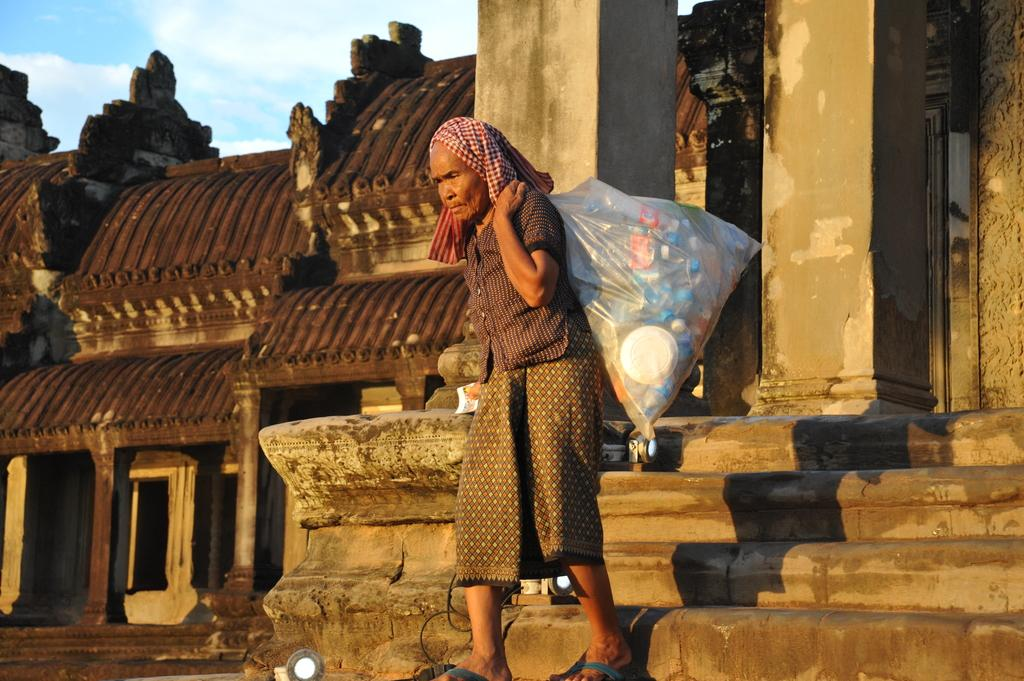Who is the main subject in the image? There is an old woman in the image. What is the old woman carrying? The old woman is carrying a bag of plastic bottles. Where is the old woman walking? The old woman is walking on the steps. What can be seen in the background of the image? There are ancient buildings in the background of the image. What is visible in the sky in the image? The sky is visible in the image, and clouds are present. What type of snake can be seen slithering on the steps in the image? There is no snake present in the image; the old woman is walking on the steps. Can you tell me how many owls are perched on the ancient buildings in the image? There are no owls present in the image; only the old woman and the ancient buildings can be seen. 